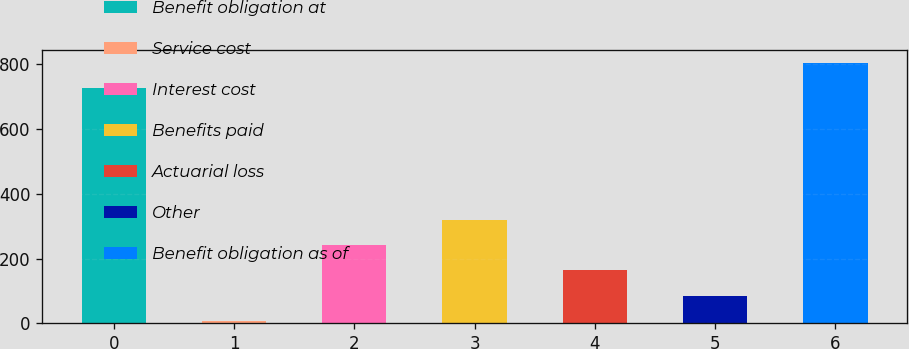Convert chart to OTSL. <chart><loc_0><loc_0><loc_500><loc_500><bar_chart><fcel>Benefit obligation at<fcel>Service cost<fcel>Interest cost<fcel>Benefits paid<fcel>Actuarial loss<fcel>Other<fcel>Benefit obligation as of<nl><fcel>727<fcel>7<fcel>242.2<fcel>320.6<fcel>163.8<fcel>85.4<fcel>805.4<nl></chart> 